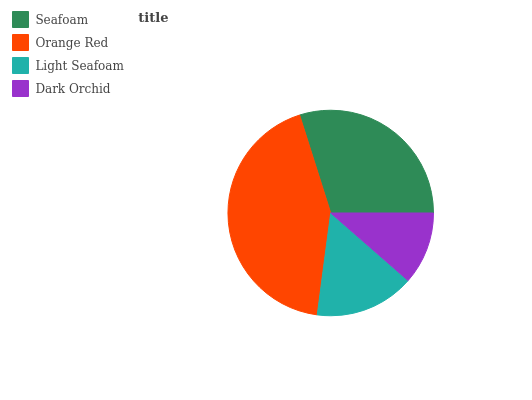Is Dark Orchid the minimum?
Answer yes or no. Yes. Is Orange Red the maximum?
Answer yes or no. Yes. Is Light Seafoam the minimum?
Answer yes or no. No. Is Light Seafoam the maximum?
Answer yes or no. No. Is Orange Red greater than Light Seafoam?
Answer yes or no. Yes. Is Light Seafoam less than Orange Red?
Answer yes or no. Yes. Is Light Seafoam greater than Orange Red?
Answer yes or no. No. Is Orange Red less than Light Seafoam?
Answer yes or no. No. Is Seafoam the high median?
Answer yes or no. Yes. Is Light Seafoam the low median?
Answer yes or no. Yes. Is Orange Red the high median?
Answer yes or no. No. Is Orange Red the low median?
Answer yes or no. No. 